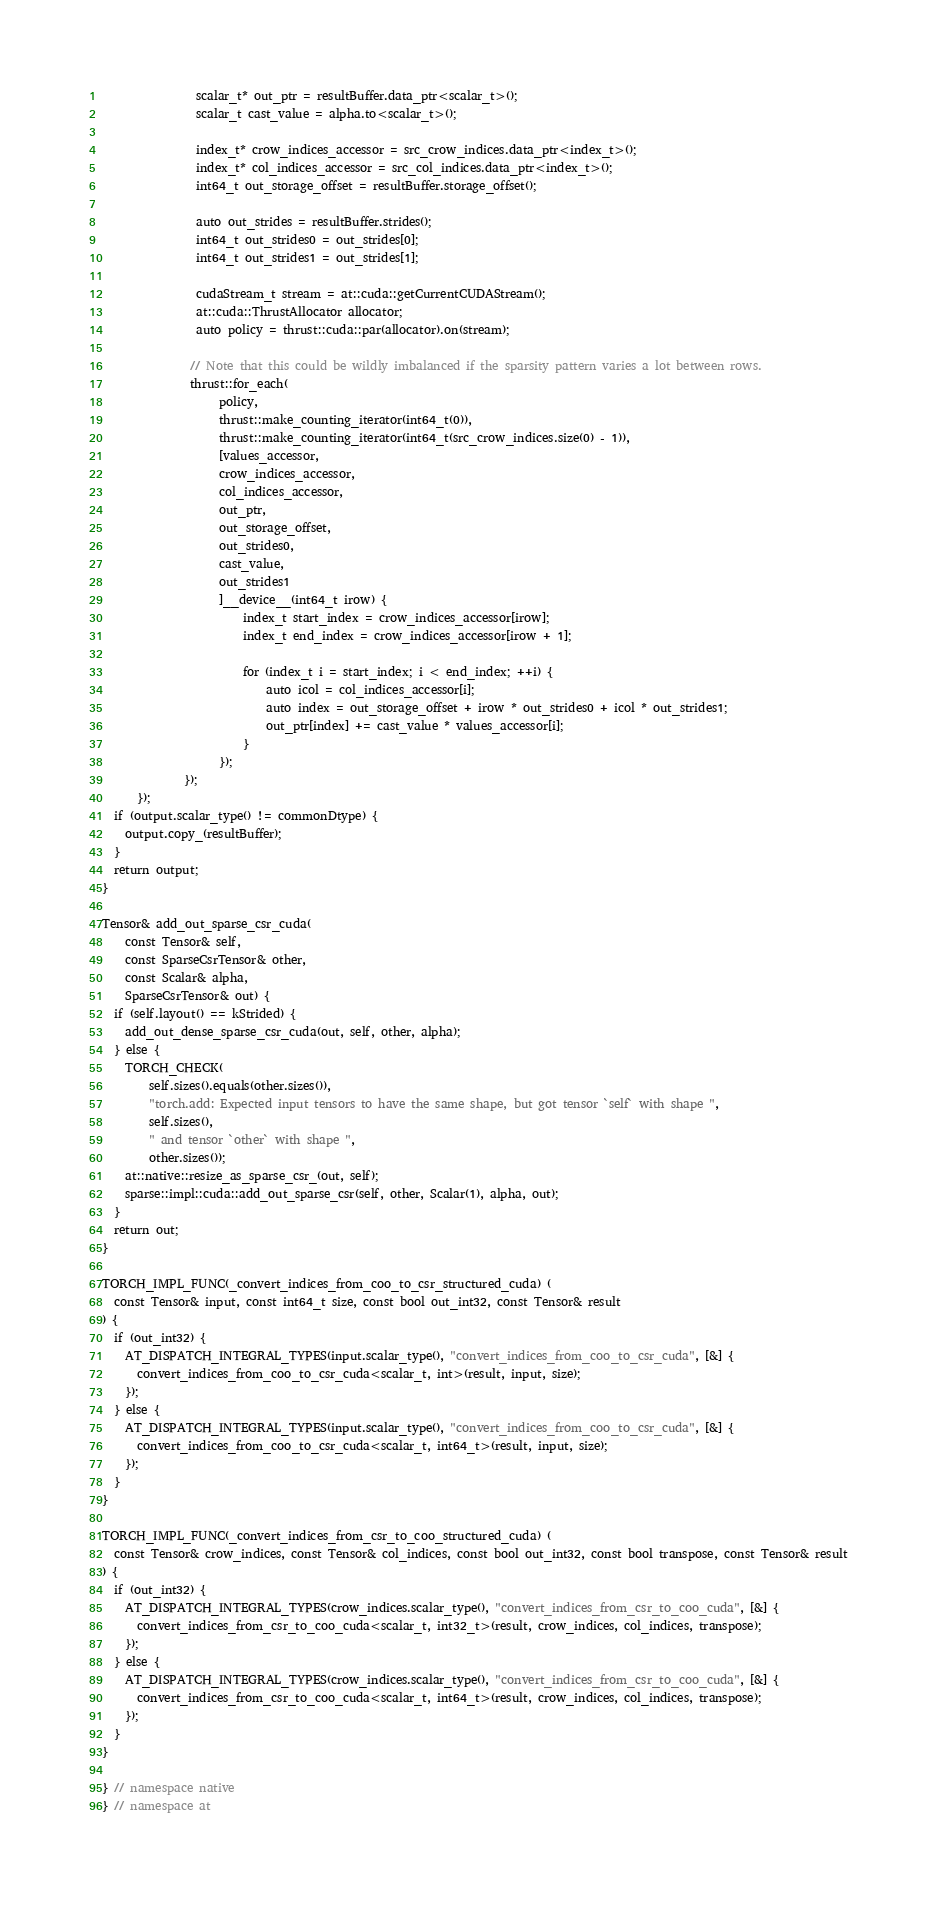<code> <loc_0><loc_0><loc_500><loc_500><_Cuda_>                scalar_t* out_ptr = resultBuffer.data_ptr<scalar_t>();
                scalar_t cast_value = alpha.to<scalar_t>();

                index_t* crow_indices_accessor = src_crow_indices.data_ptr<index_t>();
                index_t* col_indices_accessor = src_col_indices.data_ptr<index_t>();
                int64_t out_storage_offset = resultBuffer.storage_offset();

                auto out_strides = resultBuffer.strides();
                int64_t out_strides0 = out_strides[0];
                int64_t out_strides1 = out_strides[1];

                cudaStream_t stream = at::cuda::getCurrentCUDAStream();
                at::cuda::ThrustAllocator allocator;
                auto policy = thrust::cuda::par(allocator).on(stream);

               // Note that this could be wildly imbalanced if the sparsity pattern varies a lot between rows.
               thrust::for_each(
                    policy,
                    thrust::make_counting_iterator(int64_t(0)),
                    thrust::make_counting_iterator(int64_t(src_crow_indices.size(0) - 1)),
                    [values_accessor,
                    crow_indices_accessor,
                    col_indices_accessor,
                    out_ptr,
                    out_storage_offset,
                    out_strides0,
                    cast_value,
                    out_strides1
                    ]__device__(int64_t irow) {
                        index_t start_index = crow_indices_accessor[irow];
                        index_t end_index = crow_indices_accessor[irow + 1];

                        for (index_t i = start_index; i < end_index; ++i) {
                            auto icol = col_indices_accessor[i];
                            auto index = out_storage_offset + irow * out_strides0 + icol * out_strides1;
                            out_ptr[index] += cast_value * values_accessor[i];
                        }
                    });
              });
      });
  if (output.scalar_type() != commonDtype) {
    output.copy_(resultBuffer);
  }
  return output;
}

Tensor& add_out_sparse_csr_cuda(
    const Tensor& self,
    const SparseCsrTensor& other,
    const Scalar& alpha,
    SparseCsrTensor& out) {
  if (self.layout() == kStrided) {
    add_out_dense_sparse_csr_cuda(out, self, other, alpha);
  } else {
    TORCH_CHECK(
        self.sizes().equals(other.sizes()),
        "torch.add: Expected input tensors to have the same shape, but got tensor `self` with shape ",
        self.sizes(),
        " and tensor `other` with shape ",
        other.sizes());
    at::native::resize_as_sparse_csr_(out, self);
    sparse::impl::cuda::add_out_sparse_csr(self, other, Scalar(1), alpha, out);
  }
  return out;
}

TORCH_IMPL_FUNC(_convert_indices_from_coo_to_csr_structured_cuda) (
  const Tensor& input, const int64_t size, const bool out_int32, const Tensor& result
) {
  if (out_int32) {
    AT_DISPATCH_INTEGRAL_TYPES(input.scalar_type(), "convert_indices_from_coo_to_csr_cuda", [&] {
      convert_indices_from_coo_to_csr_cuda<scalar_t, int>(result, input, size);
    });
  } else {
    AT_DISPATCH_INTEGRAL_TYPES(input.scalar_type(), "convert_indices_from_coo_to_csr_cuda", [&] {
      convert_indices_from_coo_to_csr_cuda<scalar_t, int64_t>(result, input, size);
    });
  }
}

TORCH_IMPL_FUNC(_convert_indices_from_csr_to_coo_structured_cuda) (
  const Tensor& crow_indices, const Tensor& col_indices, const bool out_int32, const bool transpose, const Tensor& result
) {
  if (out_int32) {
    AT_DISPATCH_INTEGRAL_TYPES(crow_indices.scalar_type(), "convert_indices_from_csr_to_coo_cuda", [&] {
      convert_indices_from_csr_to_coo_cuda<scalar_t, int32_t>(result, crow_indices, col_indices, transpose);
    });
  } else {
    AT_DISPATCH_INTEGRAL_TYPES(crow_indices.scalar_type(), "convert_indices_from_csr_to_coo_cuda", [&] {
      convert_indices_from_csr_to_coo_cuda<scalar_t, int64_t>(result, crow_indices, col_indices, transpose);
    });
  }
}

} // namespace native
} // namespace at
</code> 